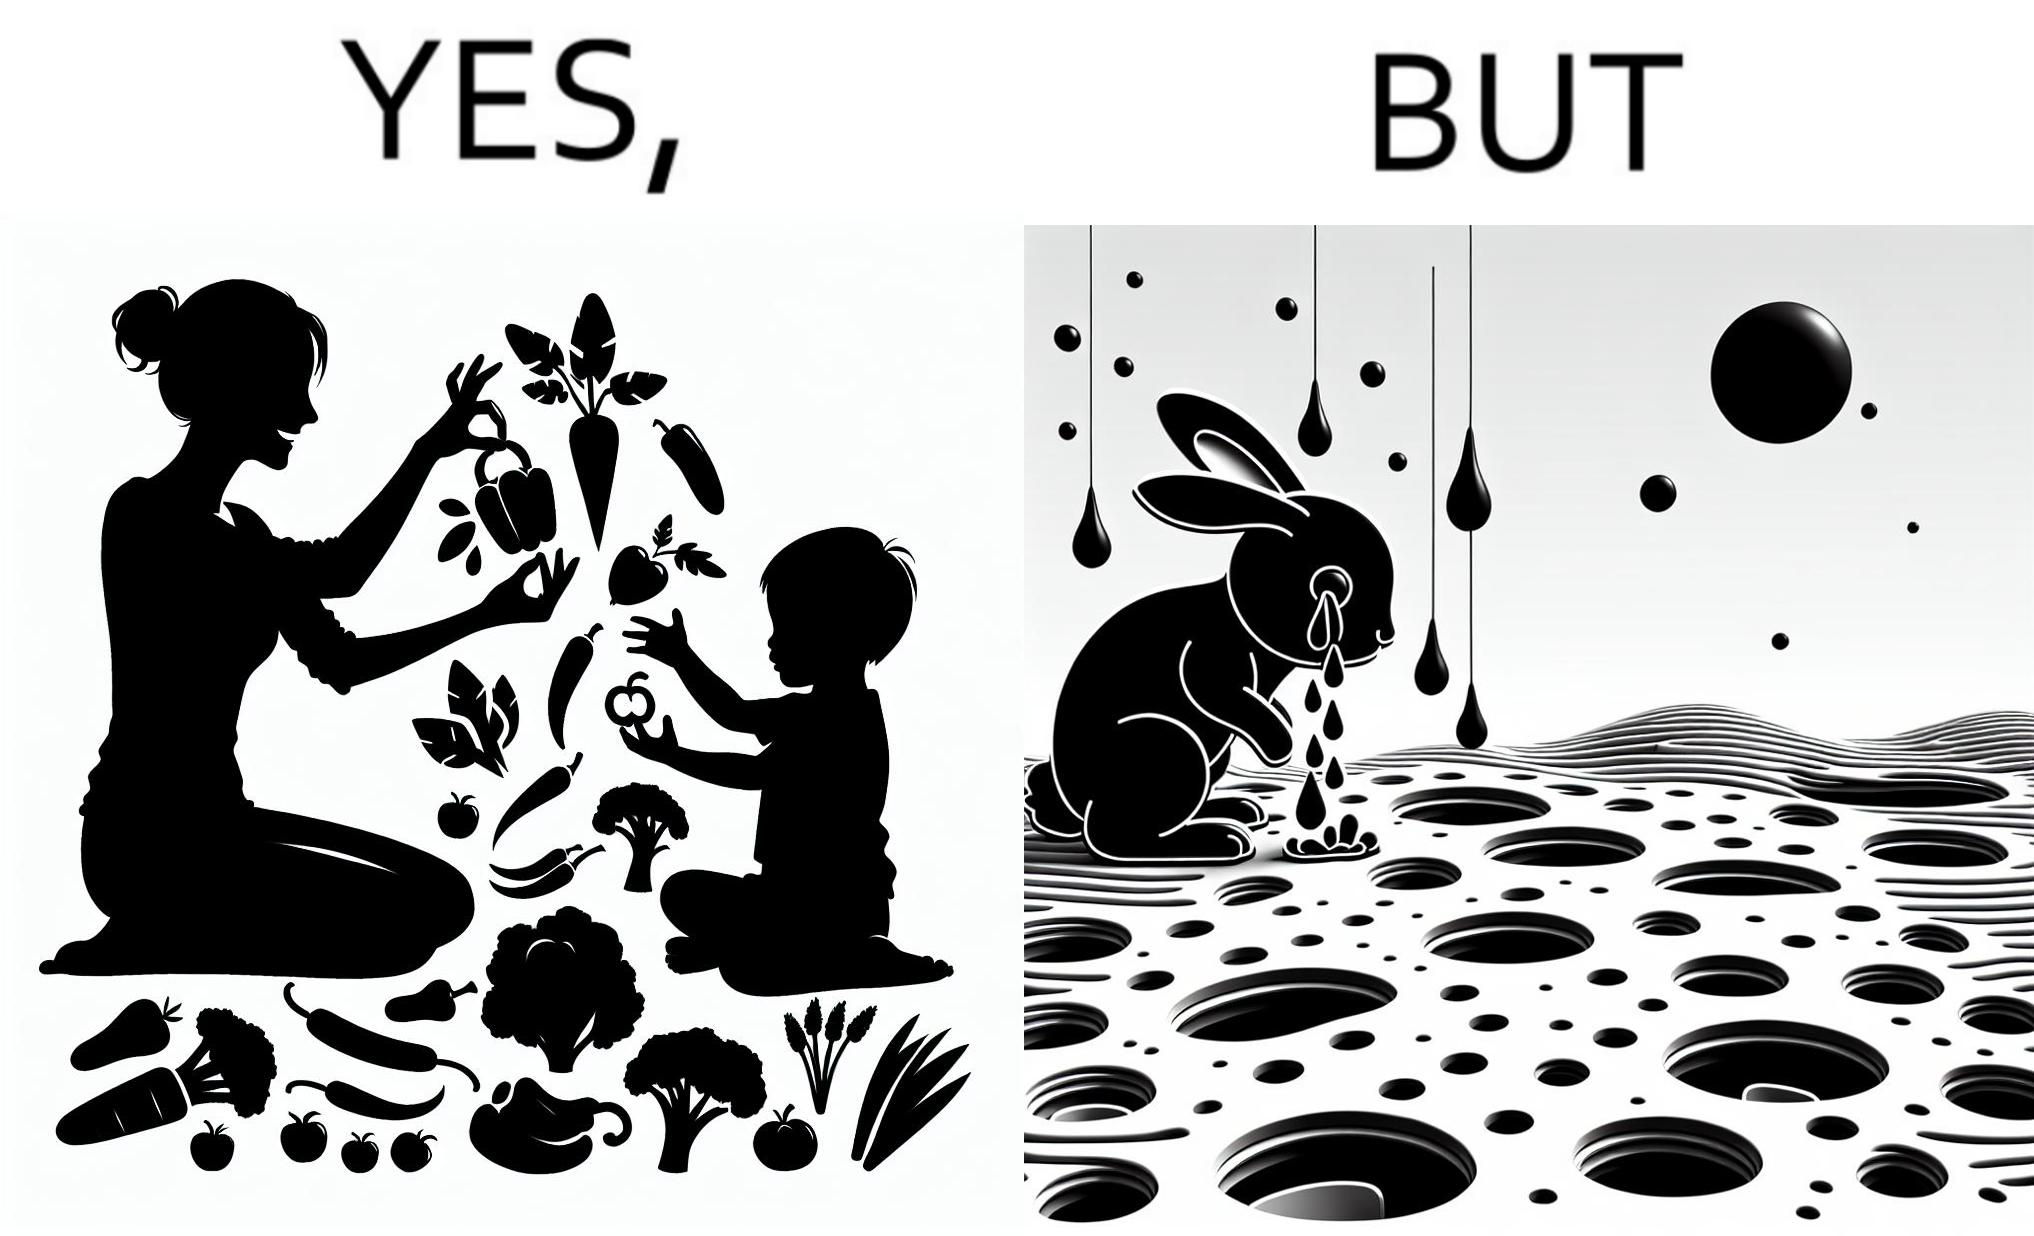What do you see in each half of this image? In the left part of the image: It is a woman and child making funny shapes with vegetables and playing with them In the right part of the image: It is rabbit crying in a ground full of holes 